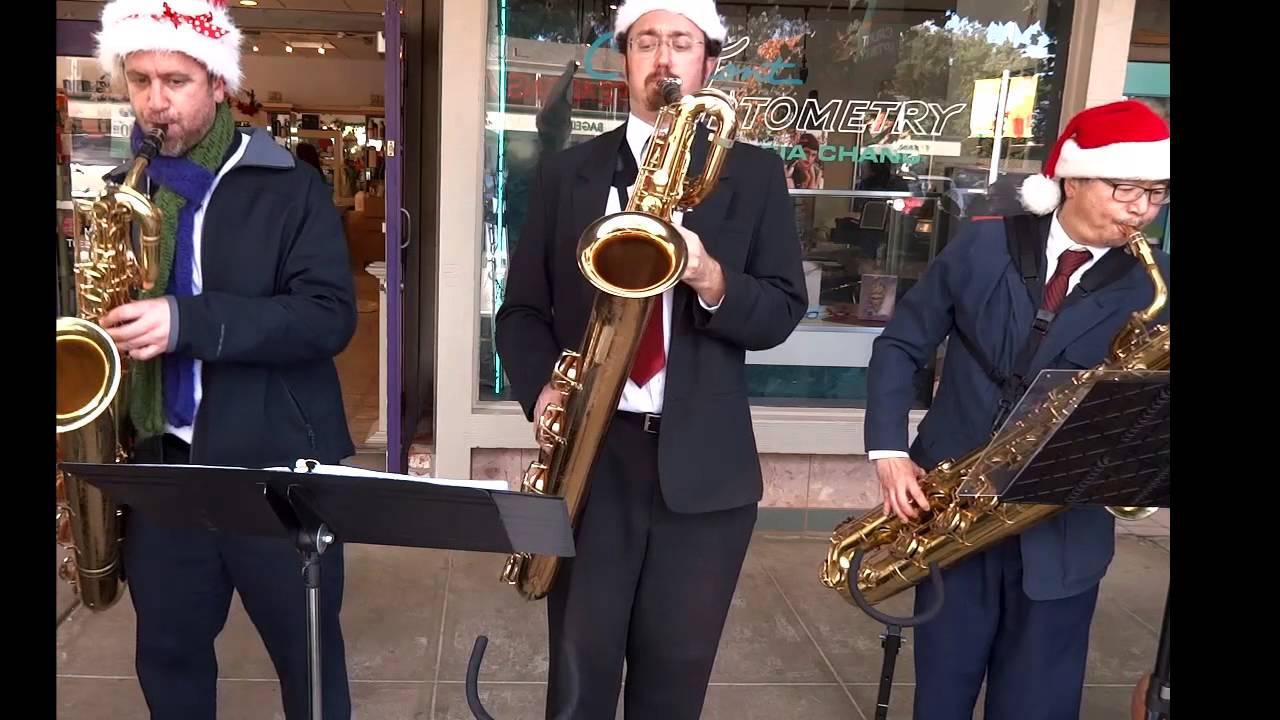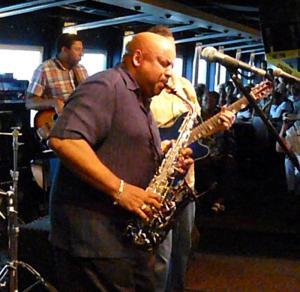The first image is the image on the left, the second image is the image on the right. For the images displayed, is the sentence "there is a bald ban holding an instrument with a bracelet  on and a short sleeved button down shirt" factually correct? Answer yes or no. Yes. The first image is the image on the left, the second image is the image on the right. Evaluate the accuracy of this statement regarding the images: "A man is holding two saxophones in the image on the left.". Is it true? Answer yes or no. No. 